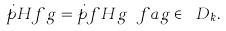Convert formula to latex. <formula><loc_0><loc_0><loc_500><loc_500>\dot { p } { H f } { g } = \dot { p } { f } { H g } \ f a g \in \ D _ { k } .</formula> 